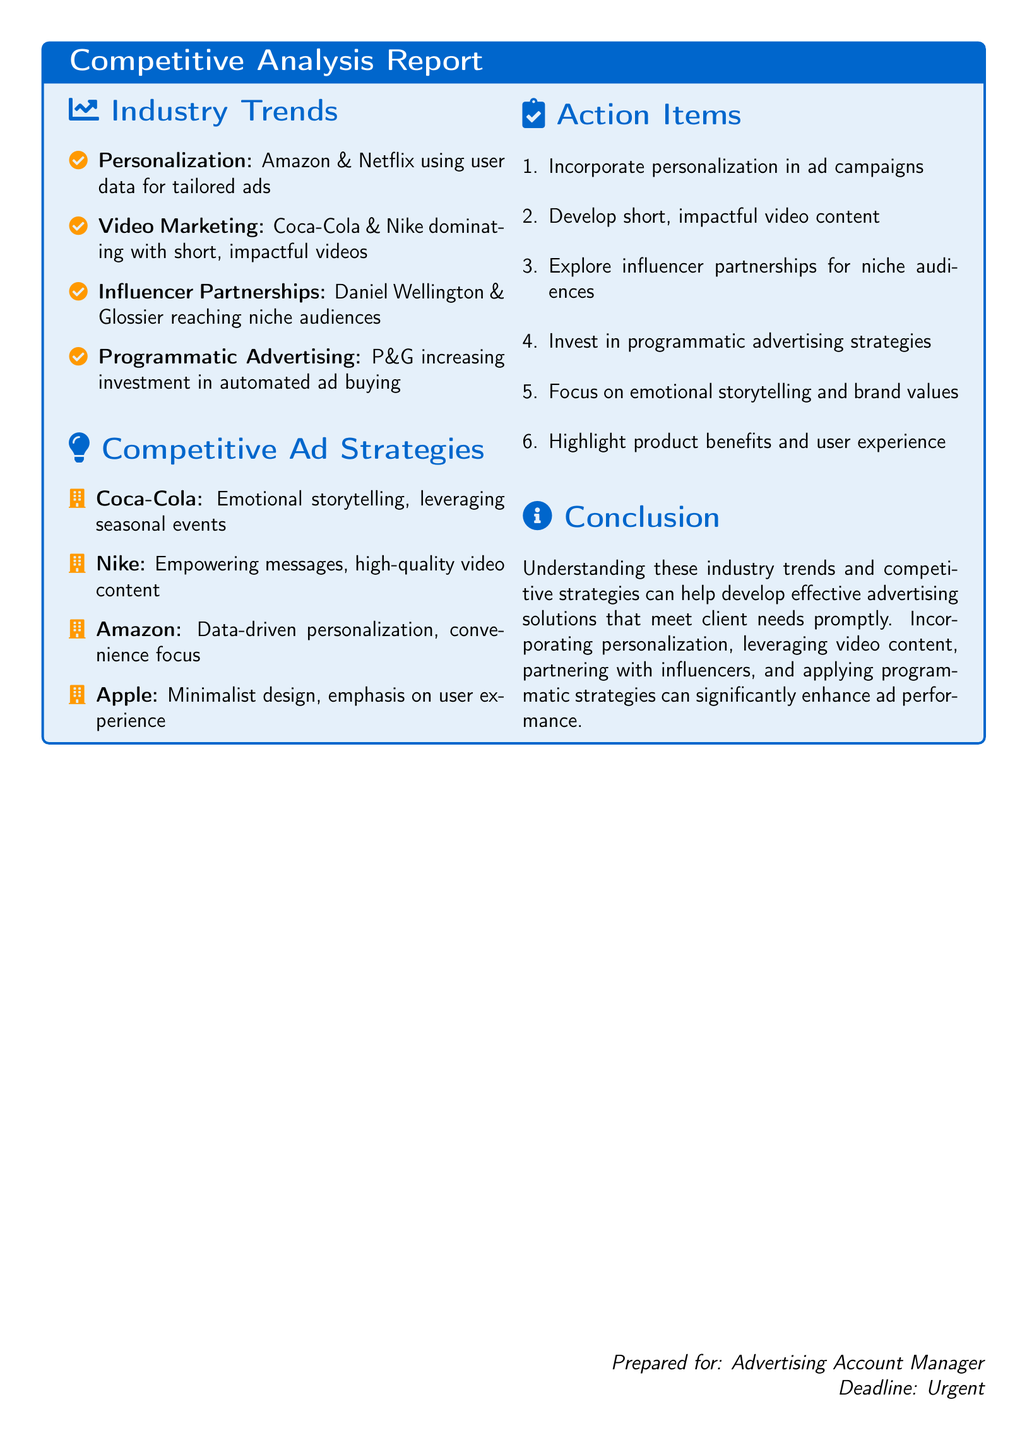What are the highlighted industry trends? The industry trends section lists four distinct trends seen in the document.
Answer: Personalization, Video Marketing, Influencer Partnerships, Programmatic Advertising Which brand uses emotional storytelling in their advertising? The competitive ad strategies section specifies Coca-Cola's use of this approach.
Answer: Coca-Cola What type of content are Coca-Cola and Nike focusing on? The document specifically notes the focus on video content.
Answer: Short, impactful videos Which advertising strategy is mentioned as being relevant for niche audiences? The document highlights influencer partnerships as a strategy for niche audiences.
Answer: Influencer partnerships What is one action item suggested in the report? The action items section includes a list where one item can be selected.
Answer: Incorporate personalization in ad campaigns How does Amazon focus their advertising strategy? The document specifies key elements of Amazon's advertising strategy in the competitive ad section.
Answer: Data-driven personalization, convenience focus Which industry trend is associated with P&G? The document directly mentions this company in the context of a specific trend.
Answer: Programmatic Advertising What is emphasized in Apple's ad strategy? The document indicates specific elements that Apple prioritizes in its strategy.
Answer: Minimalist design, emphasis on user experience 